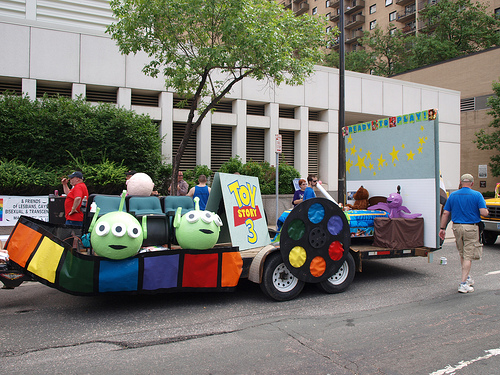<image>
Can you confirm if the blue shirt is in front of the red shirt? No. The blue shirt is not in front of the red shirt. The spatial positioning shows a different relationship between these objects. 